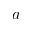Convert formula to latex. <formula><loc_0><loc_0><loc_500><loc_500>a</formula> 